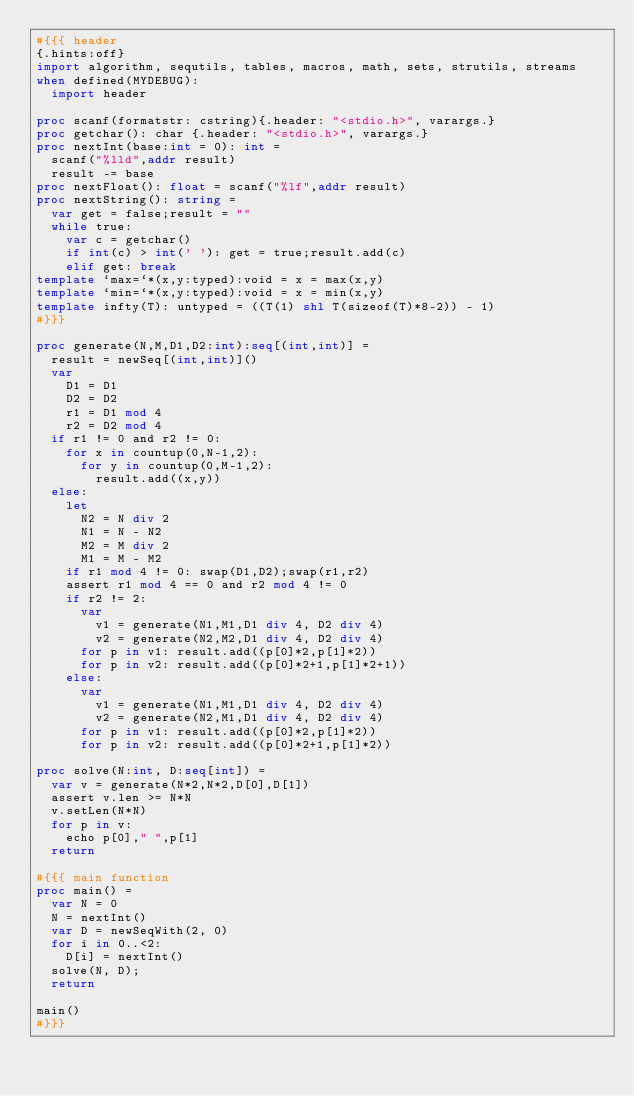<code> <loc_0><loc_0><loc_500><loc_500><_Nim_>#{{{ header
{.hints:off}
import algorithm, sequtils, tables, macros, math, sets, strutils, streams
when defined(MYDEBUG):
  import header

proc scanf(formatstr: cstring){.header: "<stdio.h>", varargs.}
proc getchar(): char {.header: "<stdio.h>", varargs.}
proc nextInt(base:int = 0): int =
  scanf("%lld",addr result)
  result -= base
proc nextFloat(): float = scanf("%lf",addr result)
proc nextString(): string =
  var get = false;result = ""
  while true:
    var c = getchar()
    if int(c) > int(' '): get = true;result.add(c)
    elif get: break
template `max=`*(x,y:typed):void = x = max(x,y)
template `min=`*(x,y:typed):void = x = min(x,y)
template infty(T): untyped = ((T(1) shl T(sizeof(T)*8-2)) - 1)
#}}}

proc generate(N,M,D1,D2:int):seq[(int,int)] = 
  result = newSeq[(int,int)]()
  var
    D1 = D1
    D2 = D2
    r1 = D1 mod 4
    r2 = D2 mod 4
  if r1 != 0 and r2 != 0:
    for x in countup(0,N-1,2):
      for y in countup(0,M-1,2):
        result.add((x,y)) 
  else:
    let
      N2 = N div 2
      N1 = N - N2
      M2 = M div 2
      M1 = M - M2
    if r1 mod 4 != 0: swap(D1,D2);swap(r1,r2)
    assert r1 mod 4 == 0 and r2 mod 4 != 0
    if r2 != 2:
      var
        v1 = generate(N1,M1,D1 div 4, D2 div 4)
        v2 = generate(N2,M2,D1 div 4, D2 div 4)
      for p in v1: result.add((p[0]*2,p[1]*2))
      for p in v2: result.add((p[0]*2+1,p[1]*2+1))
    else:
      var
        v1 = generate(N1,M1,D1 div 4, D2 div 4)
        v2 = generate(N2,M1,D1 div 4, D2 div 4)
      for p in v1: result.add((p[0]*2,p[1]*2))
      for p in v2: result.add((p[0]*2+1,p[1]*2))
  
proc solve(N:int, D:seq[int]) =
  var v = generate(N*2,N*2,D[0],D[1])
  assert v.len >= N*N
  v.setLen(N*N)
  for p in v:
    echo p[0]," ",p[1]
  return

#{{{ main function
proc main() =
  var N = 0
  N = nextInt()
  var D = newSeqWith(2, 0)
  for i in 0..<2:
    D[i] = nextInt()
  solve(N, D);
  return

main()
#}}}</code> 